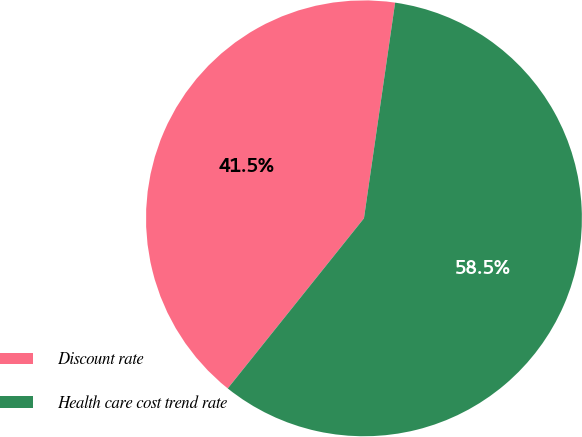Convert chart to OTSL. <chart><loc_0><loc_0><loc_500><loc_500><pie_chart><fcel>Discount rate<fcel>Health care cost trend rate<nl><fcel>41.54%<fcel>58.46%<nl></chart> 